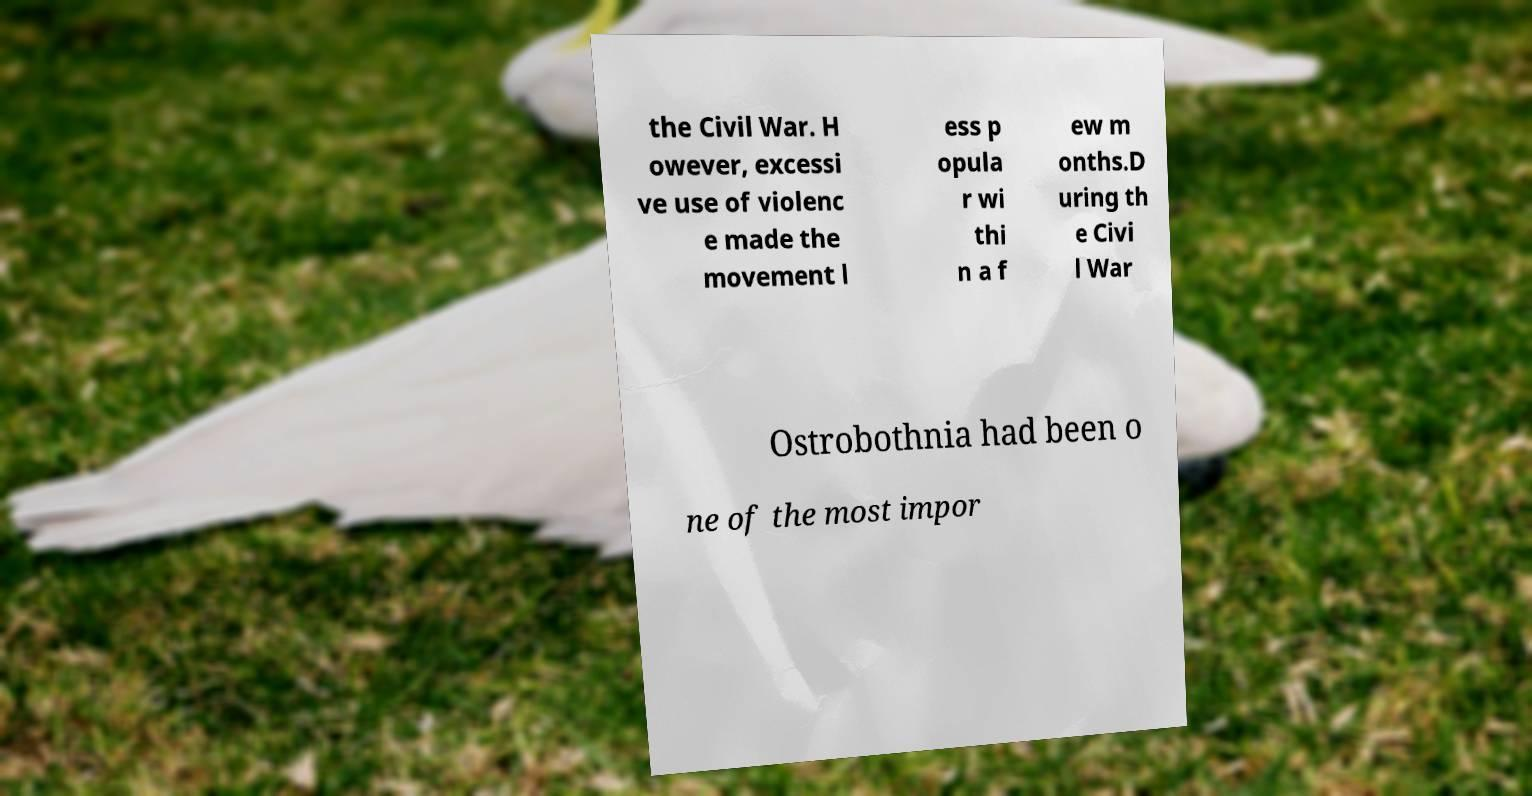Please identify and transcribe the text found in this image. the Civil War. H owever, excessi ve use of violenc e made the movement l ess p opula r wi thi n a f ew m onths.D uring th e Civi l War Ostrobothnia had been o ne of the most impor 